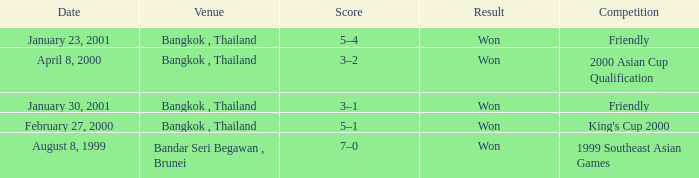What was the score from the king's cup 2000? 5–1. 